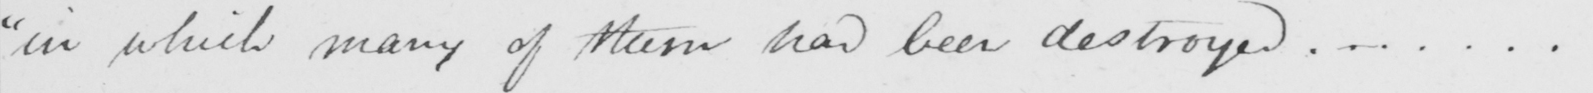Please provide the text content of this handwritten line. " in which many of them had been destroyed ...... . 